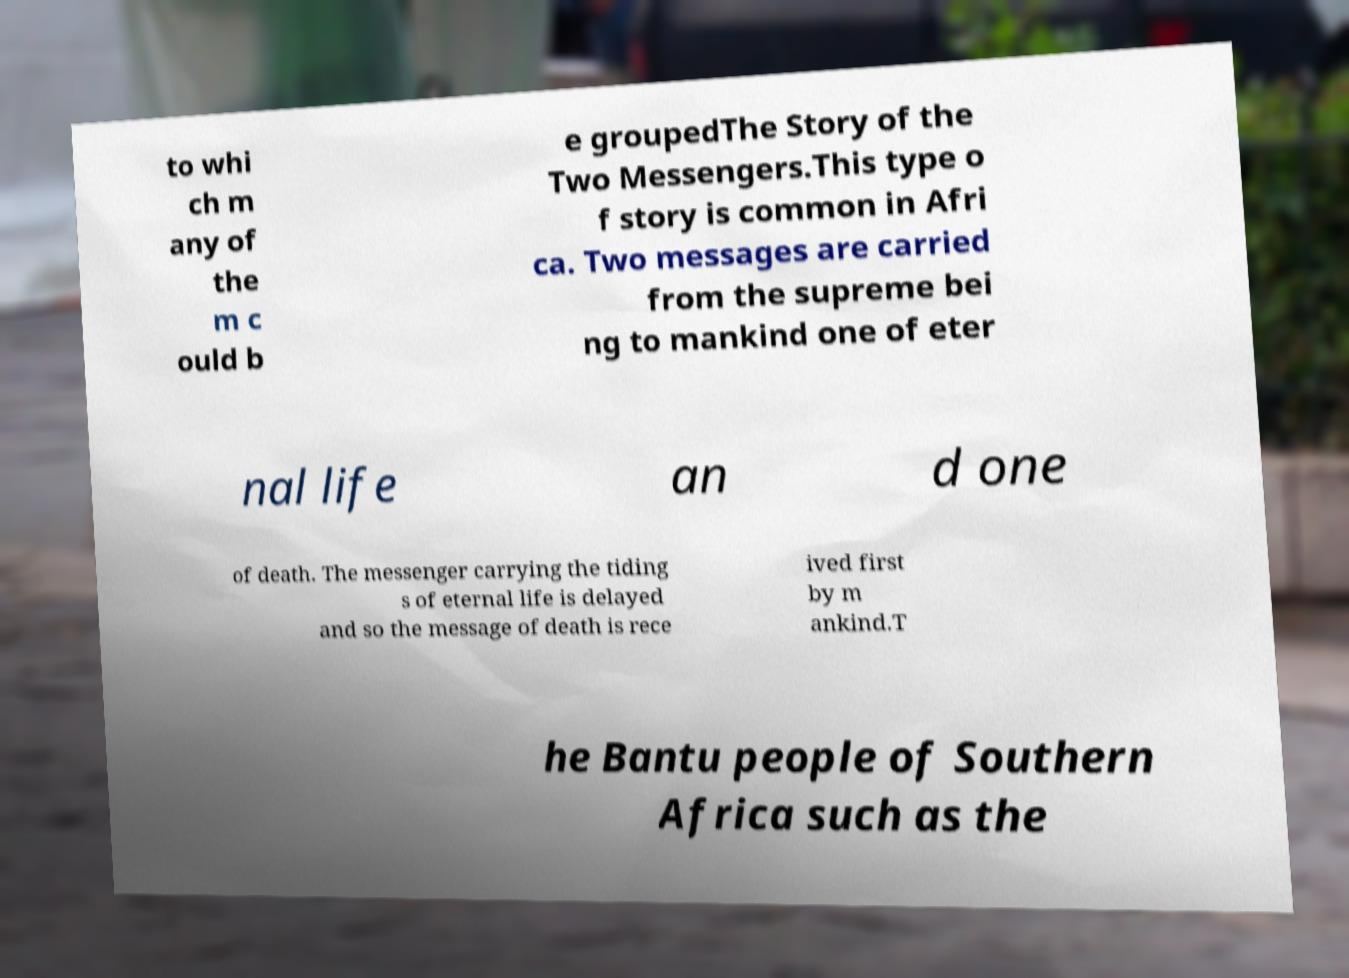For documentation purposes, I need the text within this image transcribed. Could you provide that? to whi ch m any of the m c ould b e groupedThe Story of the Two Messengers.This type o f story is common in Afri ca. Two messages are carried from the supreme bei ng to mankind one of eter nal life an d one of death. The messenger carrying the tiding s of eternal life is delayed and so the message of death is rece ived first by m ankind.T he Bantu people of Southern Africa such as the 